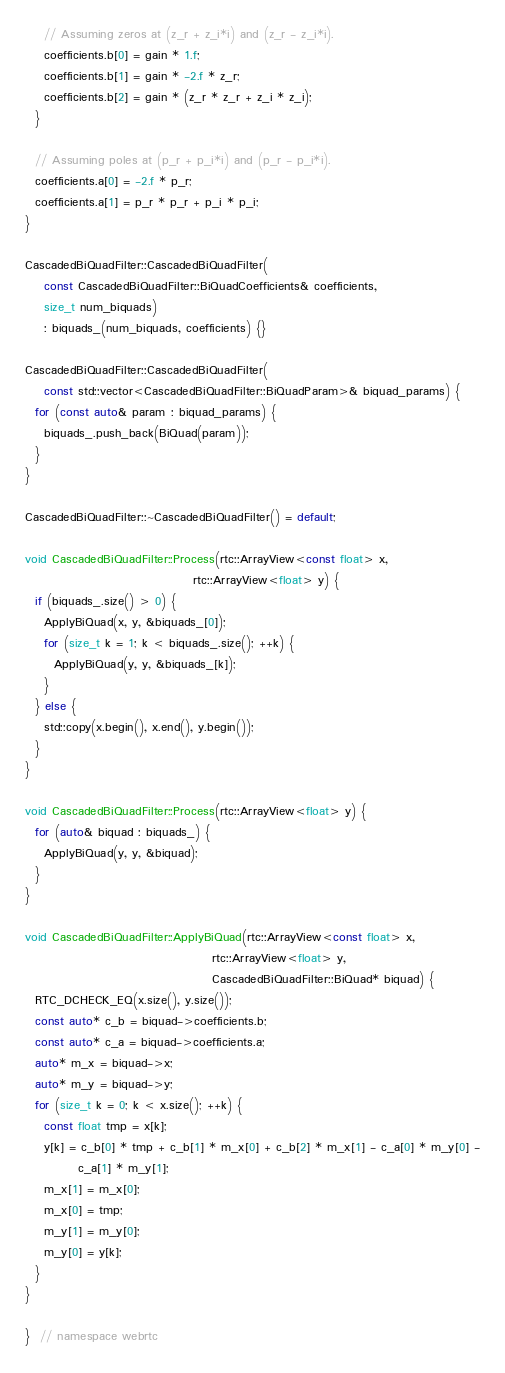Convert code to text. <code><loc_0><loc_0><loc_500><loc_500><_C++_>    // Assuming zeros at (z_r + z_i*i) and (z_r - z_i*i).
    coefficients.b[0] = gain * 1.f;
    coefficients.b[1] = gain * -2.f * z_r;
    coefficients.b[2] = gain * (z_r * z_r + z_i * z_i);
  }

  // Assuming poles at (p_r + p_i*i) and (p_r - p_i*i).
  coefficients.a[0] = -2.f * p_r;
  coefficients.a[1] = p_r * p_r + p_i * p_i;
}

CascadedBiQuadFilter::CascadedBiQuadFilter(
    const CascadedBiQuadFilter::BiQuadCoefficients& coefficients,
    size_t num_biquads)
    : biquads_(num_biquads, coefficients) {}

CascadedBiQuadFilter::CascadedBiQuadFilter(
    const std::vector<CascadedBiQuadFilter::BiQuadParam>& biquad_params) {
  for (const auto& param : biquad_params) {
    biquads_.push_back(BiQuad(param));
  }
}

CascadedBiQuadFilter::~CascadedBiQuadFilter() = default;

void CascadedBiQuadFilter::Process(rtc::ArrayView<const float> x,
                                   rtc::ArrayView<float> y) {
  if (biquads_.size() > 0) {
    ApplyBiQuad(x, y, &biquads_[0]);
    for (size_t k = 1; k < biquads_.size(); ++k) {
      ApplyBiQuad(y, y, &biquads_[k]);
    }
  } else {
    std::copy(x.begin(), x.end(), y.begin());
  }
}

void CascadedBiQuadFilter::Process(rtc::ArrayView<float> y) {
  for (auto& biquad : biquads_) {
    ApplyBiQuad(y, y, &biquad);
  }
}

void CascadedBiQuadFilter::ApplyBiQuad(rtc::ArrayView<const float> x,
                                       rtc::ArrayView<float> y,
                                       CascadedBiQuadFilter::BiQuad* biquad) {
  RTC_DCHECK_EQ(x.size(), y.size());
  const auto* c_b = biquad->coefficients.b;
  const auto* c_a = biquad->coefficients.a;
  auto* m_x = biquad->x;
  auto* m_y = biquad->y;
  for (size_t k = 0; k < x.size(); ++k) {
    const float tmp = x[k];
    y[k] = c_b[0] * tmp + c_b[1] * m_x[0] + c_b[2] * m_x[1] - c_a[0] * m_y[0] -
           c_a[1] * m_y[1];
    m_x[1] = m_x[0];
    m_x[0] = tmp;
    m_y[1] = m_y[0];
    m_y[0] = y[k];
  }
}

}  // namespace webrtc
</code> 